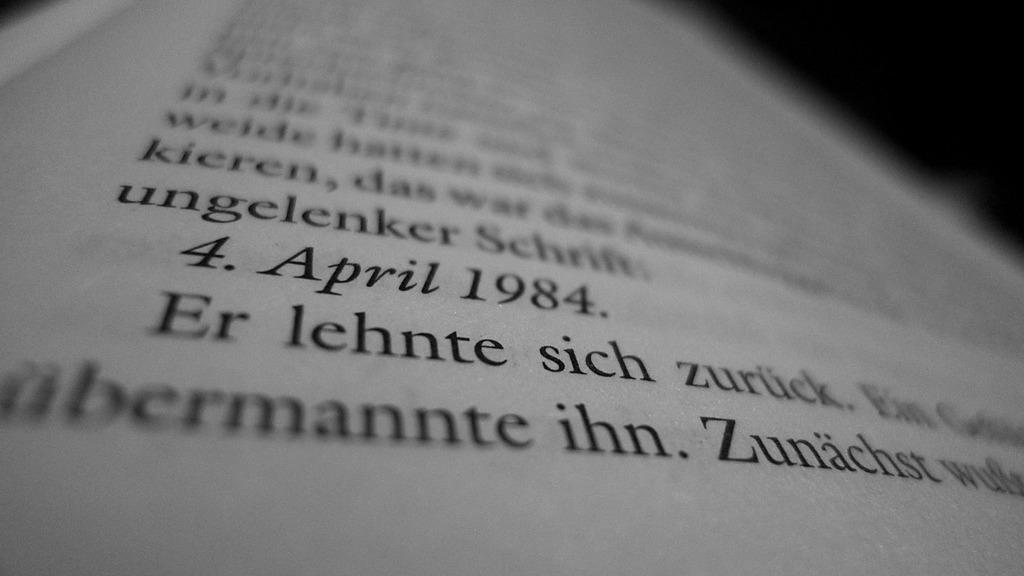<image>
Offer a succinct explanation of the picture presented. A page from a book displaying some words in German. 